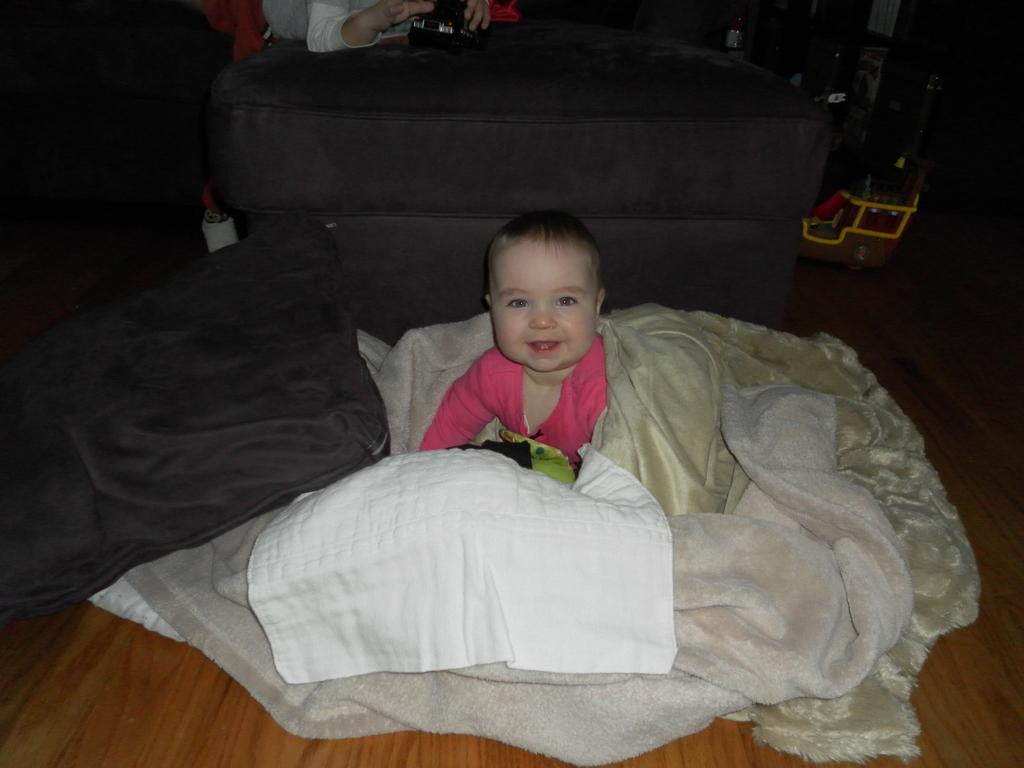What is the main subject of the image? There is a baby in the image. How is the baby positioned or covered in the image? The baby is covered with blankets. What can be seen in the background of the image? There is a sofa and a toy in the background of the image. What is on the sofa in the image? There is an object on the sofa. Is there a person present in the image? Yes, there is a person in the image. What type of jellyfish can be seen playing chess with the person in the image? There is no jellyfish or chess game present in the image. How does the person in the image communicate with the baby? The image does not show any communication between the person and the baby, so it cannot be determined from the image. 